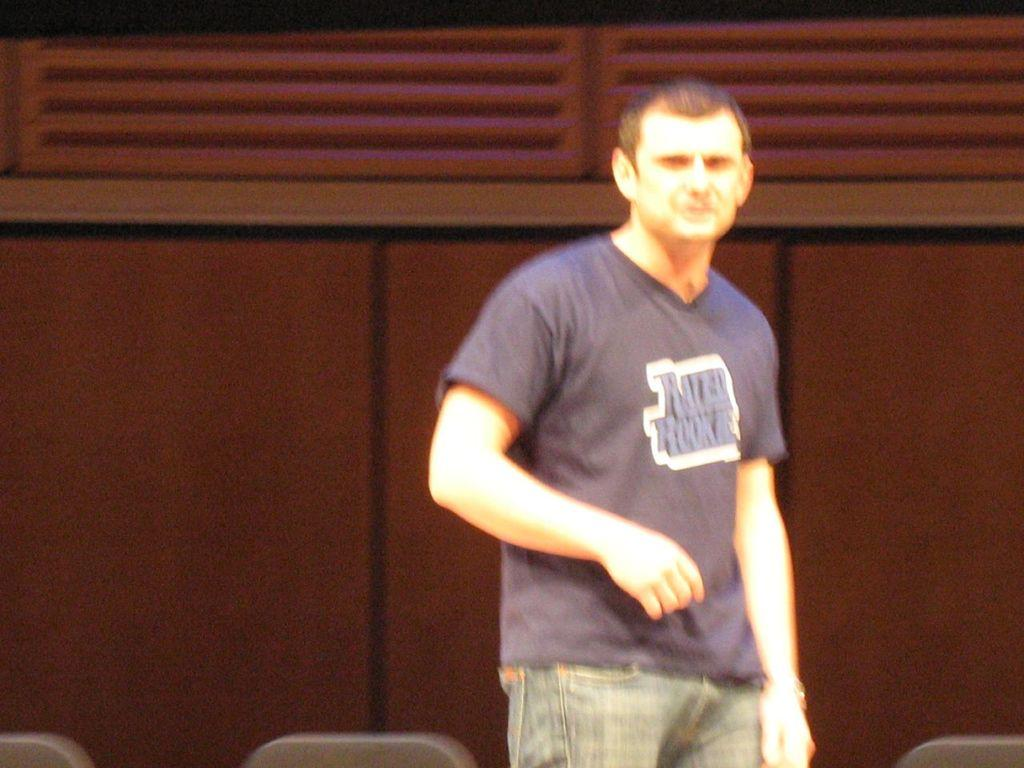What is the main subject of the image? There is a person standing in the image. Can you describe the quality of the image? The image is blurred. What type of notebook is the person holding in the image? There is no notebook present in the image. What kind of trains can be seen in the background of the image? There are no trains visible in the image. 